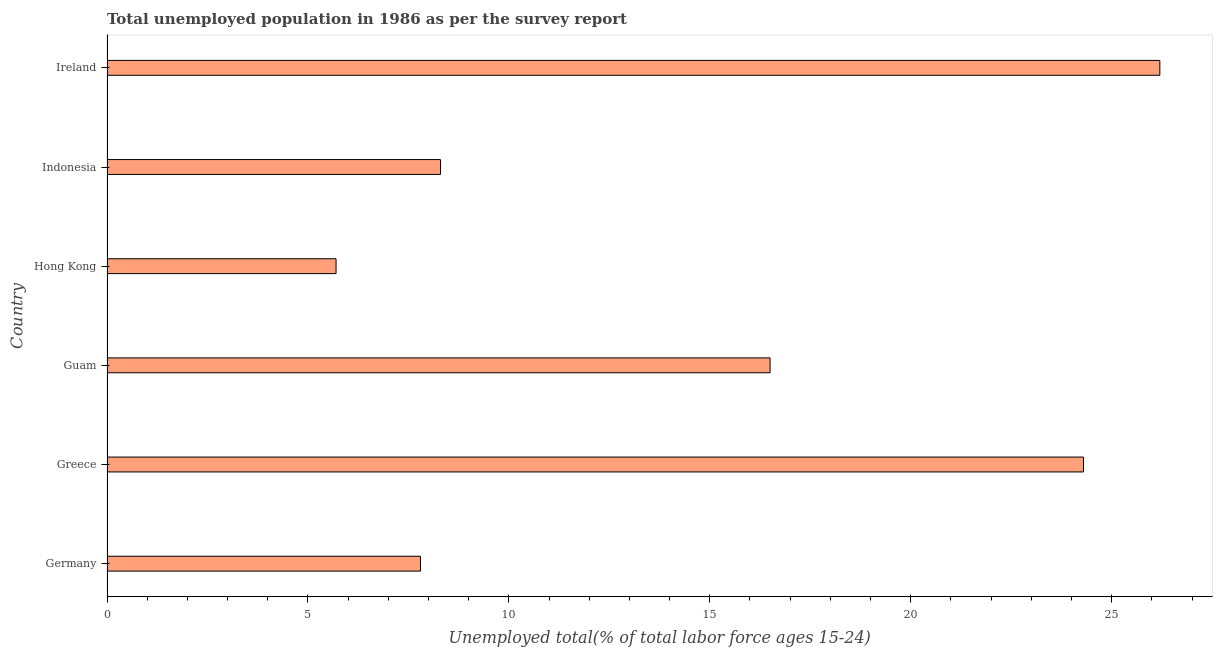Does the graph contain any zero values?
Offer a terse response. No. Does the graph contain grids?
Offer a very short reply. No. What is the title of the graph?
Provide a short and direct response. Total unemployed population in 1986 as per the survey report. What is the label or title of the X-axis?
Provide a short and direct response. Unemployed total(% of total labor force ages 15-24). What is the label or title of the Y-axis?
Keep it short and to the point. Country. What is the unemployed youth in Guam?
Provide a short and direct response. 16.5. Across all countries, what is the maximum unemployed youth?
Provide a succinct answer. 26.2. Across all countries, what is the minimum unemployed youth?
Provide a succinct answer. 5.7. In which country was the unemployed youth maximum?
Your answer should be compact. Ireland. In which country was the unemployed youth minimum?
Ensure brevity in your answer.  Hong Kong. What is the sum of the unemployed youth?
Offer a very short reply. 88.8. What is the average unemployed youth per country?
Provide a succinct answer. 14.8. What is the median unemployed youth?
Provide a succinct answer. 12.4. What is the ratio of the unemployed youth in Hong Kong to that in Indonesia?
Provide a short and direct response. 0.69. Is the unemployed youth in Hong Kong less than that in Indonesia?
Ensure brevity in your answer.  Yes. Is the difference between the unemployed youth in Germany and Guam greater than the difference between any two countries?
Make the answer very short. No. What is the difference between the highest and the lowest unemployed youth?
Your response must be concise. 20.5. What is the difference between two consecutive major ticks on the X-axis?
Ensure brevity in your answer.  5. What is the Unemployed total(% of total labor force ages 15-24) in Germany?
Ensure brevity in your answer.  7.8. What is the Unemployed total(% of total labor force ages 15-24) of Greece?
Your answer should be compact. 24.3. What is the Unemployed total(% of total labor force ages 15-24) of Guam?
Give a very brief answer. 16.5. What is the Unemployed total(% of total labor force ages 15-24) of Hong Kong?
Your answer should be very brief. 5.7. What is the Unemployed total(% of total labor force ages 15-24) of Indonesia?
Ensure brevity in your answer.  8.3. What is the Unemployed total(% of total labor force ages 15-24) of Ireland?
Provide a short and direct response. 26.2. What is the difference between the Unemployed total(% of total labor force ages 15-24) in Germany and Greece?
Offer a very short reply. -16.5. What is the difference between the Unemployed total(% of total labor force ages 15-24) in Germany and Guam?
Offer a very short reply. -8.7. What is the difference between the Unemployed total(% of total labor force ages 15-24) in Germany and Hong Kong?
Offer a very short reply. 2.1. What is the difference between the Unemployed total(% of total labor force ages 15-24) in Germany and Indonesia?
Make the answer very short. -0.5. What is the difference between the Unemployed total(% of total labor force ages 15-24) in Germany and Ireland?
Offer a very short reply. -18.4. What is the difference between the Unemployed total(% of total labor force ages 15-24) in Guam and Ireland?
Offer a terse response. -9.7. What is the difference between the Unemployed total(% of total labor force ages 15-24) in Hong Kong and Ireland?
Offer a very short reply. -20.5. What is the difference between the Unemployed total(% of total labor force ages 15-24) in Indonesia and Ireland?
Keep it short and to the point. -17.9. What is the ratio of the Unemployed total(% of total labor force ages 15-24) in Germany to that in Greece?
Keep it short and to the point. 0.32. What is the ratio of the Unemployed total(% of total labor force ages 15-24) in Germany to that in Guam?
Your answer should be compact. 0.47. What is the ratio of the Unemployed total(% of total labor force ages 15-24) in Germany to that in Hong Kong?
Your response must be concise. 1.37. What is the ratio of the Unemployed total(% of total labor force ages 15-24) in Germany to that in Indonesia?
Keep it short and to the point. 0.94. What is the ratio of the Unemployed total(% of total labor force ages 15-24) in Germany to that in Ireland?
Offer a terse response. 0.3. What is the ratio of the Unemployed total(% of total labor force ages 15-24) in Greece to that in Guam?
Offer a very short reply. 1.47. What is the ratio of the Unemployed total(% of total labor force ages 15-24) in Greece to that in Hong Kong?
Offer a very short reply. 4.26. What is the ratio of the Unemployed total(% of total labor force ages 15-24) in Greece to that in Indonesia?
Offer a very short reply. 2.93. What is the ratio of the Unemployed total(% of total labor force ages 15-24) in Greece to that in Ireland?
Give a very brief answer. 0.93. What is the ratio of the Unemployed total(% of total labor force ages 15-24) in Guam to that in Hong Kong?
Offer a terse response. 2.9. What is the ratio of the Unemployed total(% of total labor force ages 15-24) in Guam to that in Indonesia?
Provide a succinct answer. 1.99. What is the ratio of the Unemployed total(% of total labor force ages 15-24) in Guam to that in Ireland?
Your answer should be very brief. 0.63. What is the ratio of the Unemployed total(% of total labor force ages 15-24) in Hong Kong to that in Indonesia?
Your answer should be compact. 0.69. What is the ratio of the Unemployed total(% of total labor force ages 15-24) in Hong Kong to that in Ireland?
Your answer should be compact. 0.22. What is the ratio of the Unemployed total(% of total labor force ages 15-24) in Indonesia to that in Ireland?
Provide a succinct answer. 0.32. 